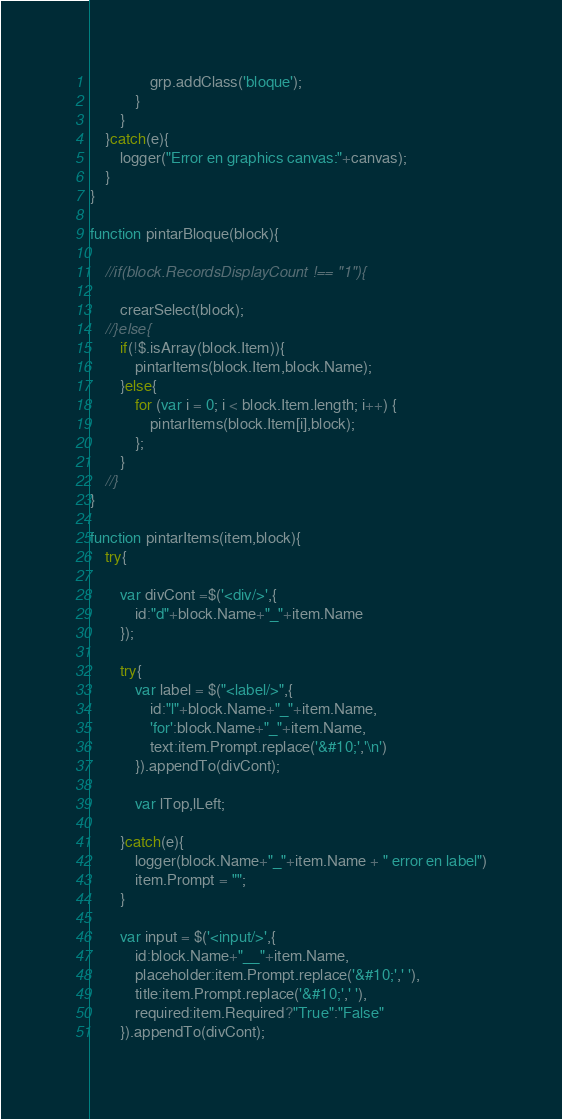<code> <loc_0><loc_0><loc_500><loc_500><_JavaScript_>				grp.addClass('bloque');
			}
		}
	}catch(e){
		logger("Error en graphics canvas:"+canvas);
	}
}

function pintarBloque(block){

	//if(block.RecordsDisplayCount !== "1"){
	
		crearSelect(block);
	//}else{
		if(!$.isArray(block.Item)){
			pintarItems(block.Item,block.Name);
		}else{
			for (var i = 0; i < block.Item.length; i++) {
				pintarItems(block.Item[i],block);
			};
		}
	//}
}

function pintarItems(item,block){
	try{

		var divCont =$('<div/>',{
			id:"d"+block.Name+"_"+item.Name
		});

		try{
			var label = $("<label/>",{
				id:"l"+block.Name+"_"+item.Name,
				'for':block.Name+"_"+item.Name,
				text:item.Prompt.replace('&#10;','\n')
			}).appendTo(divCont);

			var lTop,lLeft;

		}catch(e){
			logger(block.Name+"_"+item.Name + " error en label")
			item.Prompt = "";
		}

		var input = $('<input/>',{
			id:block.Name+"__"+item.Name,
			placeholder:item.Prompt.replace('&#10;',' '),
			title:item.Prompt.replace('&#10;',' '),
			required:item.Required?"True":"False"
		}).appendTo(divCont);
</code> 